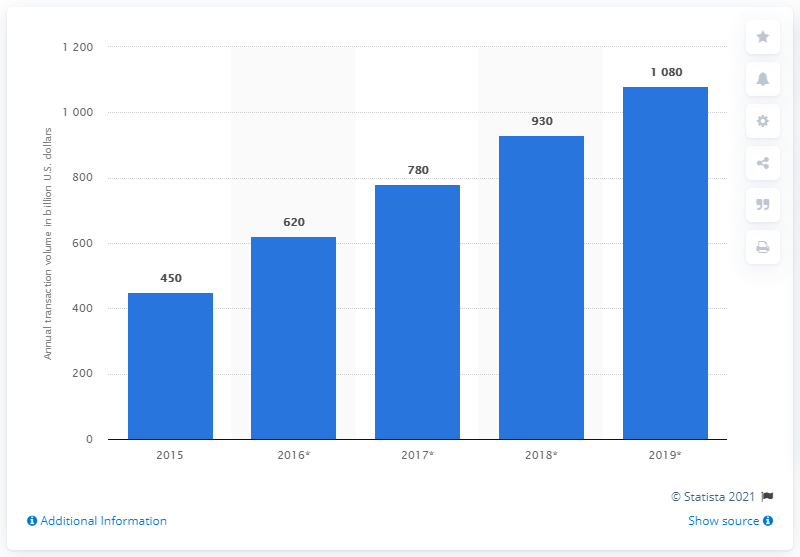Point out several critical features in this image. In 2015, the global mobile payment revenue was approximately 450. 